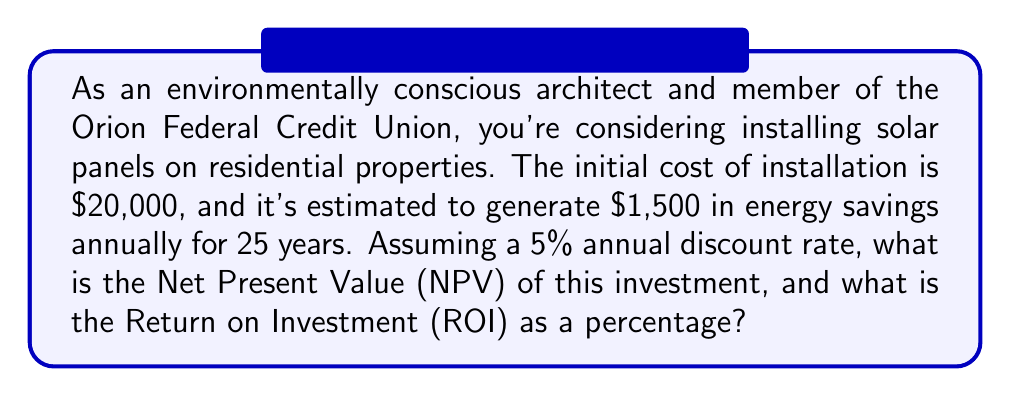Can you solve this math problem? To solve this problem, we need to calculate the Net Present Value (NPV) and then use it to determine the Return on Investment (ROI).

1. Calculate the NPV:
   The NPV is the difference between the present value of cash inflows and the present value of cash outflows over a period of time.

   NPV formula: $$ NPV = -C_0 + \sum_{t=1}^{n} \frac{C_t}{(1+r)^t} $$
   
   Where:
   $C_0$ = Initial investment
   $C_t$ = Cash flow at time t
   $r$ = Discount rate
   $n$ = Number of periods

   In this case:
   $C_0 = $20,000
   $C_t = $1,500 (annual energy savings)
   $r = 5\% = 0.05$
   $n = 25$ years

   We can use the present value of an annuity formula to simplify our calculation:
   $$ PV_{annuity} = C_t \cdot \frac{1 - (1+r)^{-n}}{r} $$

   $$ PV_{annuity} = 1500 \cdot \frac{1 - (1+0.05)^{-25}}{0.05} = $21,085.73 $$

   NPV = $-20,000 + $21,085.73 = $1,085.73

2. Calculate the ROI:
   ROI is typically calculated as: $$ ROI = \frac{\text{Net Profit}}{\text{Cost of Investment}} \times 100\% $$

   In this case, we'll use the NPV as our net profit:
   $$ ROI = \frac{1085.73}{20000} \times 100\% = 5.43\% $$
Answer: The Net Present Value (NPV) of the investment is $1,085.73, and the Return on Investment (ROI) is 5.43%. 